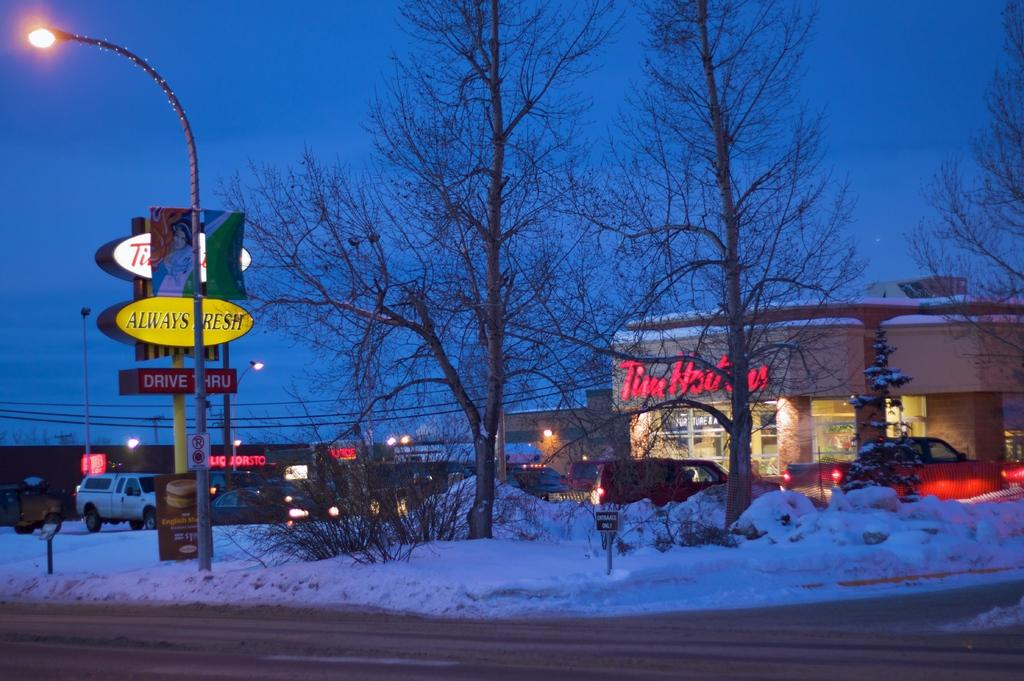<image>
Relay a brief, clear account of the picture shown. The yellow sign on this snowy road states Always Fresh. 